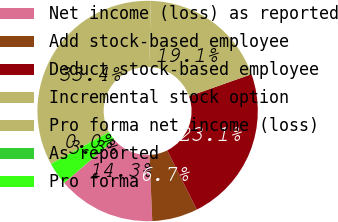<chart> <loc_0><loc_0><loc_500><loc_500><pie_chart><fcel>Net income (loss) as reported<fcel>Add stock-based employee<fcel>Deduct stock-based employee<fcel>Incremental stock option<fcel>Pro forma net income (loss)<fcel>As reported<fcel>Pro forma<nl><fcel>14.35%<fcel>6.69%<fcel>23.06%<fcel>19.11%<fcel>33.45%<fcel>0.0%<fcel>3.35%<nl></chart> 